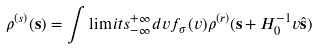Convert formula to latex. <formula><loc_0><loc_0><loc_500><loc_500>\rho ^ { ( s ) } ( { \mathbf s } ) = \int \lim i t s _ { - \infty } ^ { + \infty } d v f _ { \sigma } ( v ) \rho ^ { ( r ) } ( { \mathbf s } + H _ { 0 } ^ { - 1 } v \hat { \mathbf s } )</formula> 